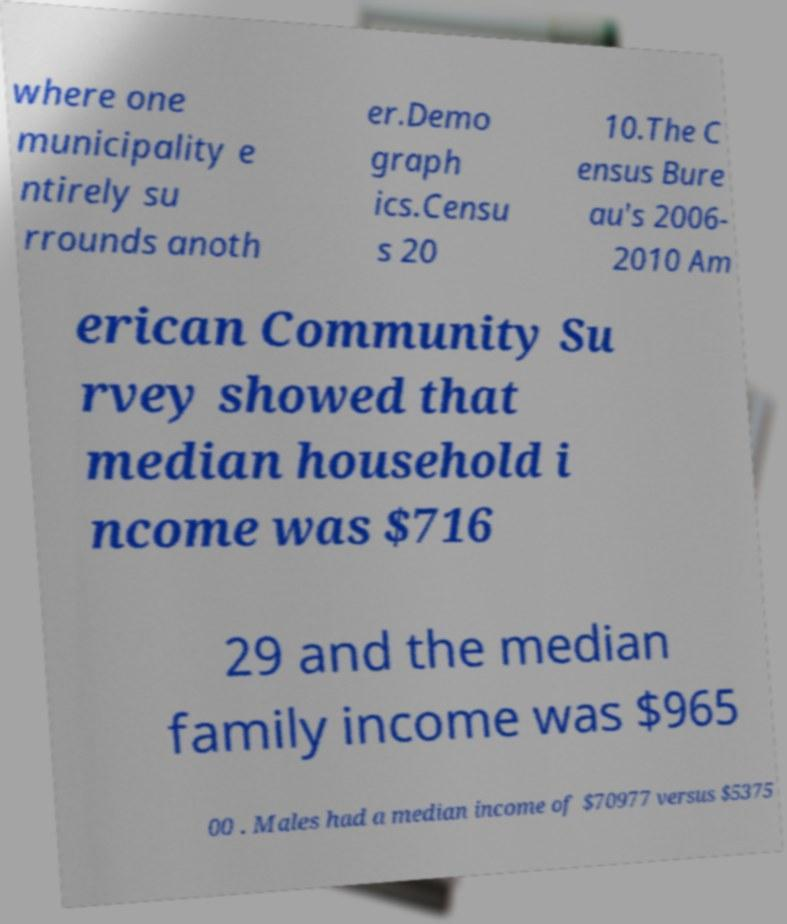Could you extract and type out the text from this image? where one municipality e ntirely su rrounds anoth er.Demo graph ics.Censu s 20 10.The C ensus Bure au's 2006- 2010 Am erican Community Su rvey showed that median household i ncome was $716 29 and the median family income was $965 00 . Males had a median income of $70977 versus $5375 